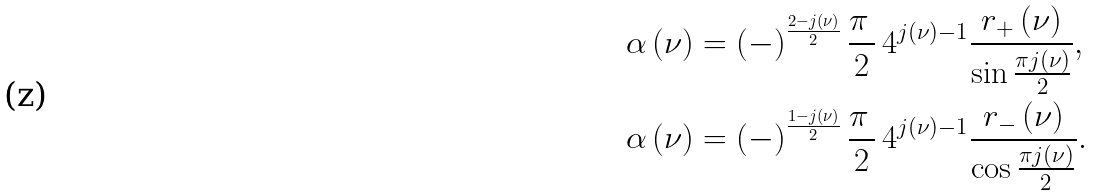<formula> <loc_0><loc_0><loc_500><loc_500>\alpha \left ( \nu \right ) & = \left ( - \right ) ^ { \frac { 2 - j \left ( \nu \right ) } { 2 } } \frac { \pi \, } { 2 } \, 4 ^ { j \left ( \nu \right ) - 1 } \frac { r _ { + } \left ( \nu \right ) } { \sin \frac { \pi j \left ( \nu \right ) } { 2 } } , \\ \alpha \left ( \nu \right ) & = \left ( - \right ) ^ { \frac { 1 - j \left ( \nu \right ) } { 2 } } \frac { \pi \, } { 2 } \, 4 ^ { j \left ( \nu \right ) - 1 } \frac { r _ { - } \left ( \nu \right ) } { \cos \frac { \pi j \left ( \nu \right ) } { 2 } } .</formula> 